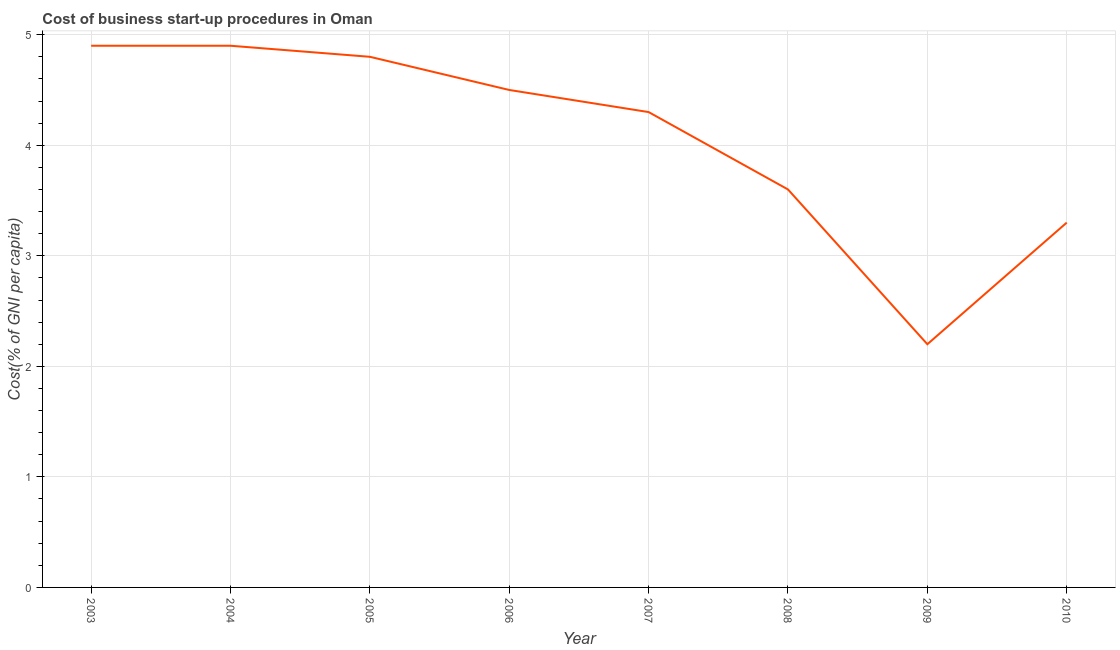What is the cost of business startup procedures in 2010?
Make the answer very short. 3.3. Across all years, what is the maximum cost of business startup procedures?
Offer a very short reply. 4.9. Across all years, what is the minimum cost of business startup procedures?
Give a very brief answer. 2.2. In which year was the cost of business startup procedures minimum?
Your answer should be very brief. 2009. What is the sum of the cost of business startup procedures?
Offer a terse response. 32.5. What is the difference between the cost of business startup procedures in 2004 and 2005?
Ensure brevity in your answer.  0.1. What is the average cost of business startup procedures per year?
Offer a very short reply. 4.06. What is the median cost of business startup procedures?
Provide a short and direct response. 4.4. Do a majority of the years between 2006 and 2008 (inclusive) have cost of business startup procedures greater than 4.8 %?
Ensure brevity in your answer.  No. What is the ratio of the cost of business startup procedures in 2005 to that in 2008?
Provide a short and direct response. 1.33. What is the difference between the highest and the second highest cost of business startup procedures?
Offer a terse response. 0. What is the difference between the highest and the lowest cost of business startup procedures?
Ensure brevity in your answer.  2.7. In how many years, is the cost of business startup procedures greater than the average cost of business startup procedures taken over all years?
Provide a succinct answer. 5. Does the cost of business startup procedures monotonically increase over the years?
Offer a very short reply. No. What is the difference between two consecutive major ticks on the Y-axis?
Make the answer very short. 1. What is the title of the graph?
Offer a very short reply. Cost of business start-up procedures in Oman. What is the label or title of the X-axis?
Give a very brief answer. Year. What is the label or title of the Y-axis?
Your response must be concise. Cost(% of GNI per capita). What is the Cost(% of GNI per capita) of 2003?
Your answer should be very brief. 4.9. What is the Cost(% of GNI per capita) in 2004?
Provide a short and direct response. 4.9. What is the Cost(% of GNI per capita) in 2005?
Make the answer very short. 4.8. What is the Cost(% of GNI per capita) in 2006?
Ensure brevity in your answer.  4.5. What is the Cost(% of GNI per capita) of 2008?
Your answer should be very brief. 3.6. What is the Cost(% of GNI per capita) of 2010?
Make the answer very short. 3.3. What is the difference between the Cost(% of GNI per capita) in 2003 and 2006?
Make the answer very short. 0.4. What is the difference between the Cost(% of GNI per capita) in 2003 and 2007?
Provide a succinct answer. 0.6. What is the difference between the Cost(% of GNI per capita) in 2003 and 2008?
Ensure brevity in your answer.  1.3. What is the difference between the Cost(% of GNI per capita) in 2004 and 2008?
Provide a succinct answer. 1.3. What is the difference between the Cost(% of GNI per capita) in 2005 and 2006?
Your answer should be very brief. 0.3. What is the difference between the Cost(% of GNI per capita) in 2005 and 2007?
Your answer should be compact. 0.5. What is the difference between the Cost(% of GNI per capita) in 2005 and 2010?
Provide a succinct answer. 1.5. What is the difference between the Cost(% of GNI per capita) in 2006 and 2007?
Your answer should be very brief. 0.2. What is the difference between the Cost(% of GNI per capita) in 2006 and 2008?
Your answer should be very brief. 0.9. What is the difference between the Cost(% of GNI per capita) in 2006 and 2009?
Your answer should be compact. 2.3. What is the difference between the Cost(% of GNI per capita) in 2007 and 2008?
Your answer should be compact. 0.7. What is the difference between the Cost(% of GNI per capita) in 2007 and 2010?
Your answer should be very brief. 1. What is the ratio of the Cost(% of GNI per capita) in 2003 to that in 2005?
Ensure brevity in your answer.  1.02. What is the ratio of the Cost(% of GNI per capita) in 2003 to that in 2006?
Your answer should be very brief. 1.09. What is the ratio of the Cost(% of GNI per capita) in 2003 to that in 2007?
Provide a short and direct response. 1.14. What is the ratio of the Cost(% of GNI per capita) in 2003 to that in 2008?
Your answer should be very brief. 1.36. What is the ratio of the Cost(% of GNI per capita) in 2003 to that in 2009?
Ensure brevity in your answer.  2.23. What is the ratio of the Cost(% of GNI per capita) in 2003 to that in 2010?
Give a very brief answer. 1.49. What is the ratio of the Cost(% of GNI per capita) in 2004 to that in 2005?
Make the answer very short. 1.02. What is the ratio of the Cost(% of GNI per capita) in 2004 to that in 2006?
Provide a succinct answer. 1.09. What is the ratio of the Cost(% of GNI per capita) in 2004 to that in 2007?
Give a very brief answer. 1.14. What is the ratio of the Cost(% of GNI per capita) in 2004 to that in 2008?
Provide a short and direct response. 1.36. What is the ratio of the Cost(% of GNI per capita) in 2004 to that in 2009?
Keep it short and to the point. 2.23. What is the ratio of the Cost(% of GNI per capita) in 2004 to that in 2010?
Your response must be concise. 1.49. What is the ratio of the Cost(% of GNI per capita) in 2005 to that in 2006?
Make the answer very short. 1.07. What is the ratio of the Cost(% of GNI per capita) in 2005 to that in 2007?
Keep it short and to the point. 1.12. What is the ratio of the Cost(% of GNI per capita) in 2005 to that in 2008?
Ensure brevity in your answer.  1.33. What is the ratio of the Cost(% of GNI per capita) in 2005 to that in 2009?
Offer a terse response. 2.18. What is the ratio of the Cost(% of GNI per capita) in 2005 to that in 2010?
Provide a short and direct response. 1.46. What is the ratio of the Cost(% of GNI per capita) in 2006 to that in 2007?
Your answer should be very brief. 1.05. What is the ratio of the Cost(% of GNI per capita) in 2006 to that in 2008?
Offer a very short reply. 1.25. What is the ratio of the Cost(% of GNI per capita) in 2006 to that in 2009?
Your answer should be very brief. 2.04. What is the ratio of the Cost(% of GNI per capita) in 2006 to that in 2010?
Ensure brevity in your answer.  1.36. What is the ratio of the Cost(% of GNI per capita) in 2007 to that in 2008?
Keep it short and to the point. 1.19. What is the ratio of the Cost(% of GNI per capita) in 2007 to that in 2009?
Your answer should be very brief. 1.96. What is the ratio of the Cost(% of GNI per capita) in 2007 to that in 2010?
Your answer should be very brief. 1.3. What is the ratio of the Cost(% of GNI per capita) in 2008 to that in 2009?
Your answer should be very brief. 1.64. What is the ratio of the Cost(% of GNI per capita) in 2008 to that in 2010?
Your answer should be compact. 1.09. What is the ratio of the Cost(% of GNI per capita) in 2009 to that in 2010?
Your response must be concise. 0.67. 